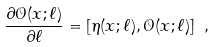<formula> <loc_0><loc_0><loc_500><loc_500>\frac { \partial { \mathcal { O } } ( x ; \ell ) } { \partial \ell } = [ \eta ( x ; \ell ) , { \mathcal { O } } ( x ; \ell ) ] \ ,</formula> 